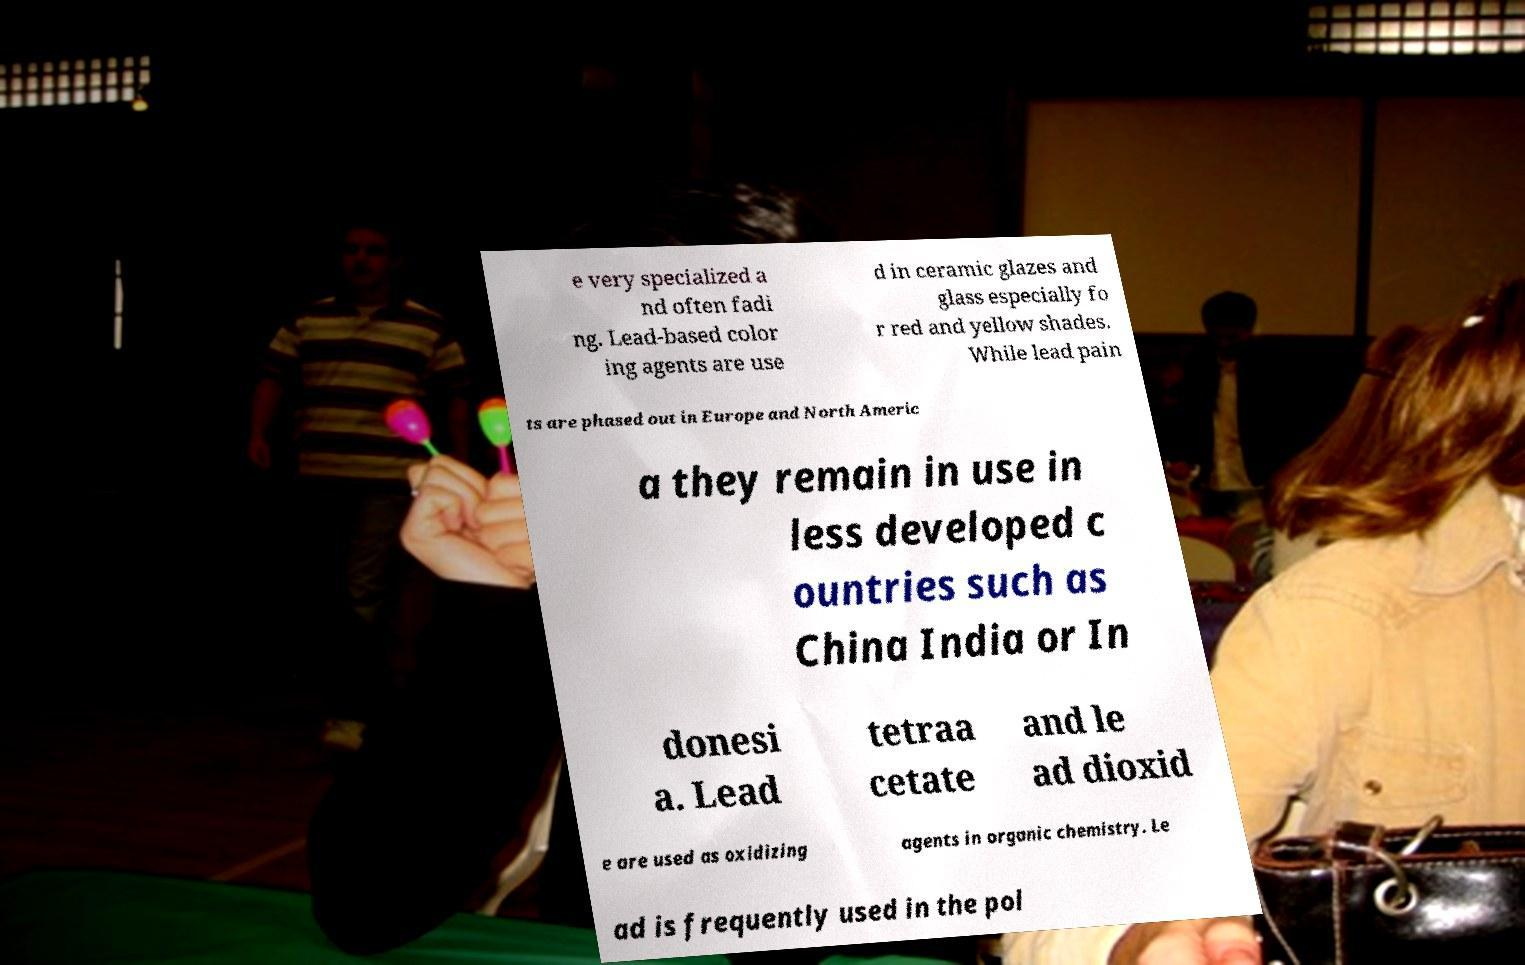Could you assist in decoding the text presented in this image and type it out clearly? e very specialized a nd often fadi ng. Lead-based color ing agents are use d in ceramic glazes and glass especially fo r red and yellow shades. While lead pain ts are phased out in Europe and North Americ a they remain in use in less developed c ountries such as China India or In donesi a. Lead tetraa cetate and le ad dioxid e are used as oxidizing agents in organic chemistry. Le ad is frequently used in the pol 